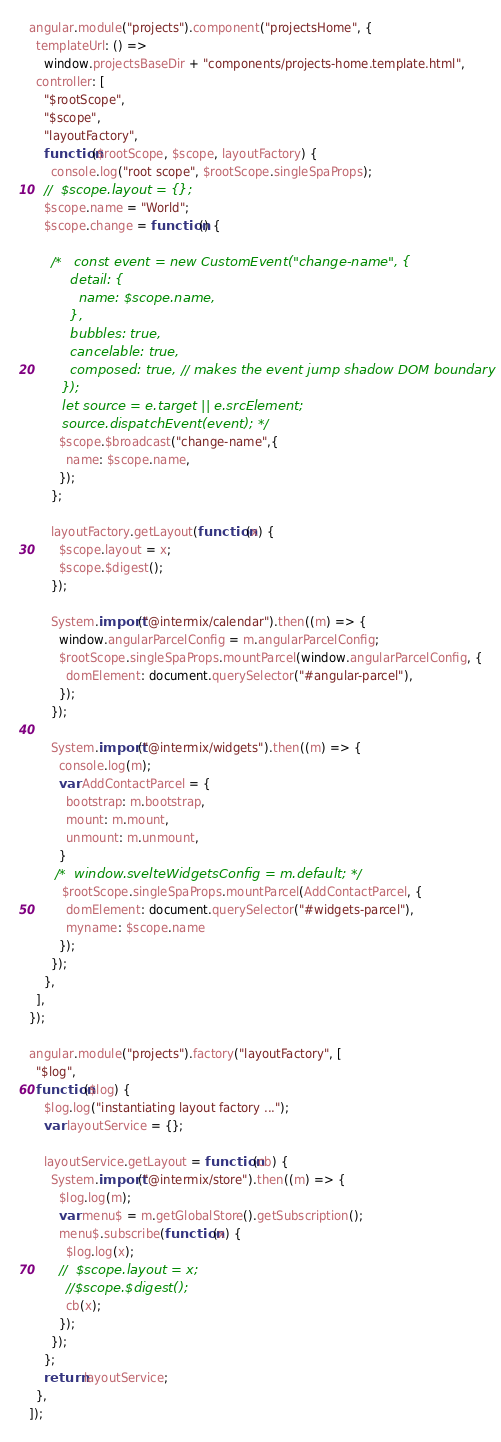Convert code to text. <code><loc_0><loc_0><loc_500><loc_500><_JavaScript_>angular.module("projects").component("projectsHome", {
  templateUrl: () =>
    window.projectsBaseDir + "components/projects-home.template.html",
  controller: [
    "$rootScope",
    "$scope",
    "layoutFactory",
    function($rootScope, $scope, layoutFactory) {
      console.log("root scope", $rootScope.singleSpaProps);
    //  $scope.layout = {};
    $scope.name = "World";
    $scope.change = function() {
      
      /*   const event = new CustomEvent("change-name", {
          detail: {
            name: $scope.name,
          },
          bubbles: true,
          cancelable: true,
          composed: true, // makes the event jump shadow DOM boundary
        });
        let source = e.target || e.srcElement;
        source.dispatchEvent(event); */
        $scope.$broadcast("change-name",{
          name: $scope.name,
        });
      };
    
      layoutFactory.getLayout(function(x) {
        $scope.layout = x;
        $scope.$digest();
      });

      System.import("@intermix/calendar").then((m) => {
        window.angularParcelConfig = m.angularParcelConfig;
        $rootScope.singleSpaProps.mountParcel(window.angularParcelConfig, {
          domElement: document.querySelector("#angular-parcel"),
        });
      });

      System.import("@intermix/widgets").then((m) => {
        console.log(m);
        var AddContactParcel = {
          bootstrap: m.bootstrap,
          mount: m.mount,
          unmount: m.unmount,
        }
       /*  window.svelteWidgetsConfig = m.default; */
         $rootScope.singleSpaProps.mountParcel(AddContactParcel, {
          domElement: document.querySelector("#widgets-parcel"),
          myname: $scope.name
        });  
      });
    },
  ],
});

angular.module("projects").factory("layoutFactory", [
  "$log",
  function($log) {
    $log.log("instantiating layout factory ...");
    var layoutService = {};

    layoutService.getLayout = function(cb) {
      System.import("@intermix/store").then((m) => {
        $log.log(m);
        var menu$ = m.getGlobalStore().getSubscription();
        menu$.subscribe(function(x) {
          $log.log(x);
        //  $scope.layout = x;
          //$scope.$digest();
          cb(x);
        });
      });
    };
    return layoutService;
  },
]);
</code> 